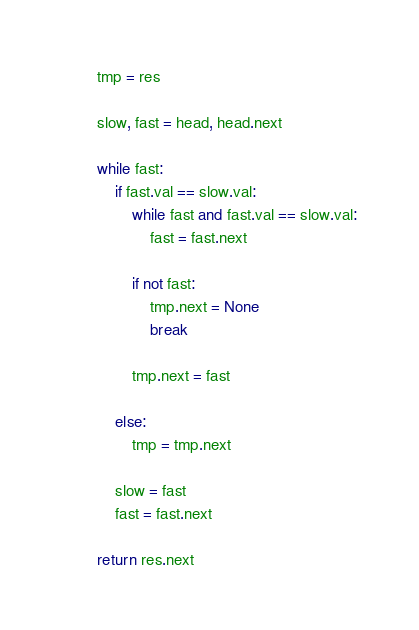Convert code to text. <code><loc_0><loc_0><loc_500><loc_500><_Python_>        tmp = res

        slow, fast = head, head.next

        while fast:
            if fast.val == slow.val:
                while fast and fast.val == slow.val:
                    fast = fast.next

                if not fast:
                    tmp.next = None
                    break

                tmp.next = fast

            else:
                tmp = tmp.next

            slow = fast
            fast = fast.next

        return res.next
</code> 